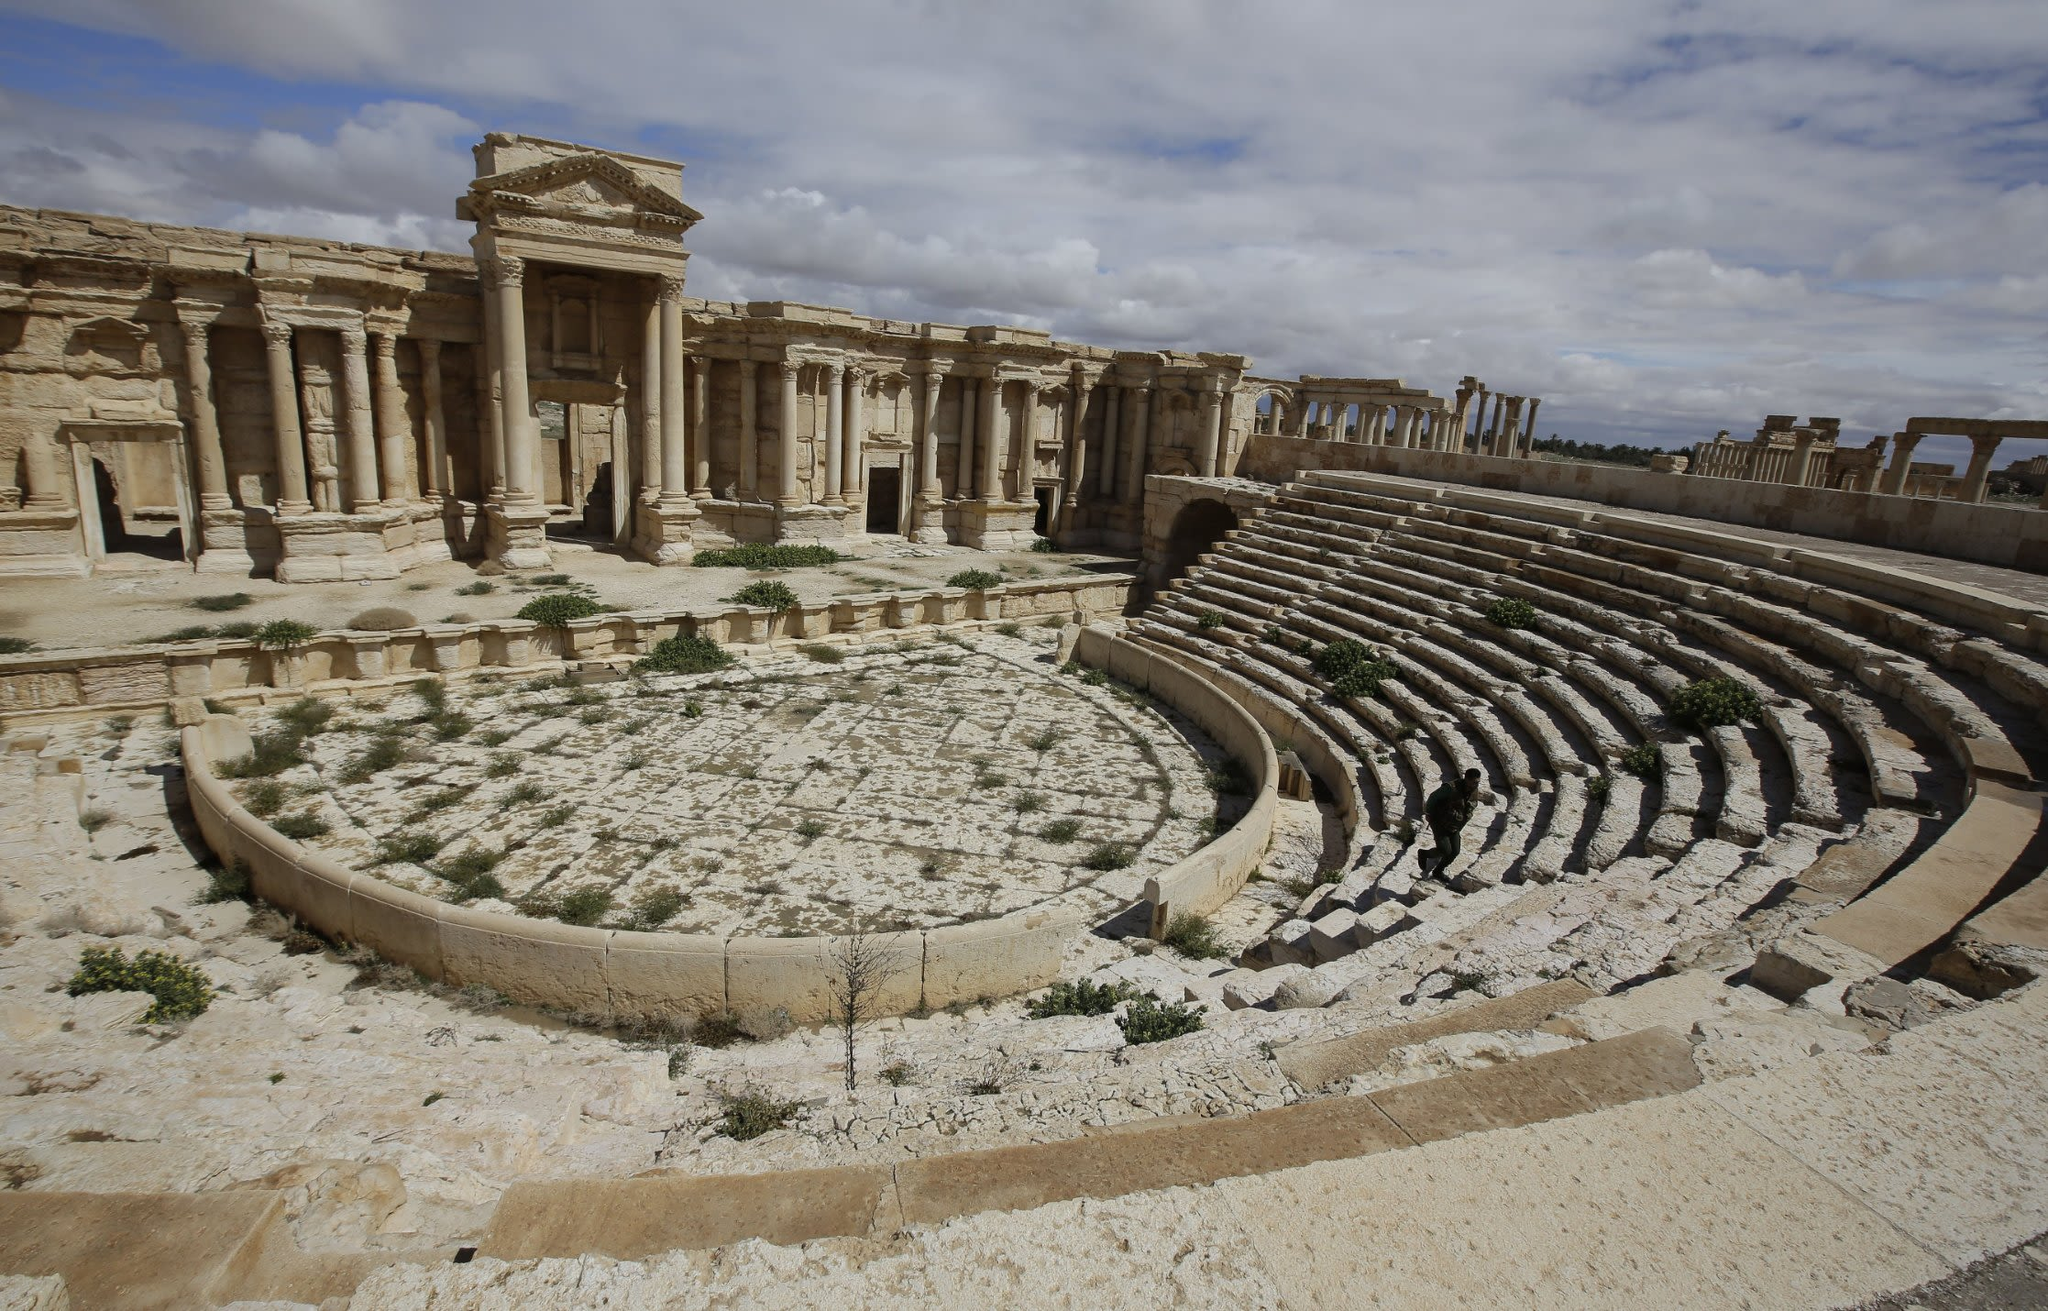How would you feel walking through this ancient theater? Walking through the ancient theater of Palmyra, a profound mixture of awe and melancholy would wash over you. The grandeur of the architecture, even in its ruined state, evokes admiration for the ingenuity and artistry of the ancient builders. Every broken stone and column tells a story of a time when the theater was alive with the sound of music, laughter, and applause. The silence now is heavy, reminding you of the passage of time and the impermanence of human endeavors. You might feel a deep connection to the past, almost hearing echoes of ancient performances, and a respect for the resilience of history that survived through centuries of turmoil. The experience would be humbling and reflective, a journey back in time.  Can you write a poem inspired by this theater? In ancient stones where shadows play,
A theater stands, worn by decay.
Its seats, once full, now stand stark bare,
Whispers of ghosts linger in the air.

Columns rise to kiss the sky,
Silent guardians of days gone by.
On this stage, where stories spun,
Echoes of time, a race now run.

Sandstone whispers ancient lore,
Of laughs, of tears, of war and more.
Sky above, a somber gray,
Mourns the glory of yesterday.

Yet in the quiet, still remains,
A beauty wrought from past remains.
A testament in stone and air,
The ancient theater stands, still fair. 